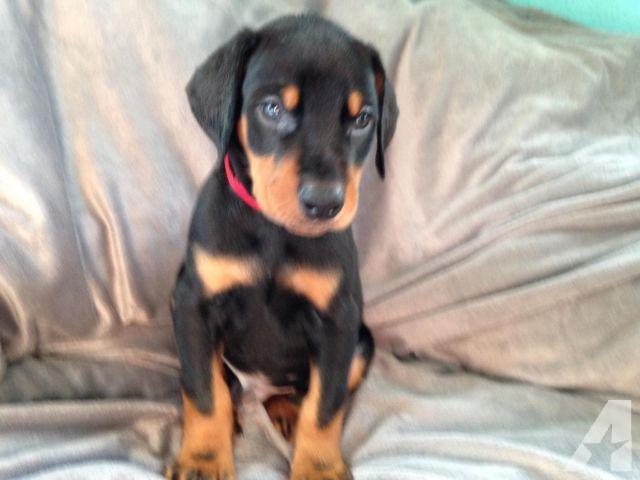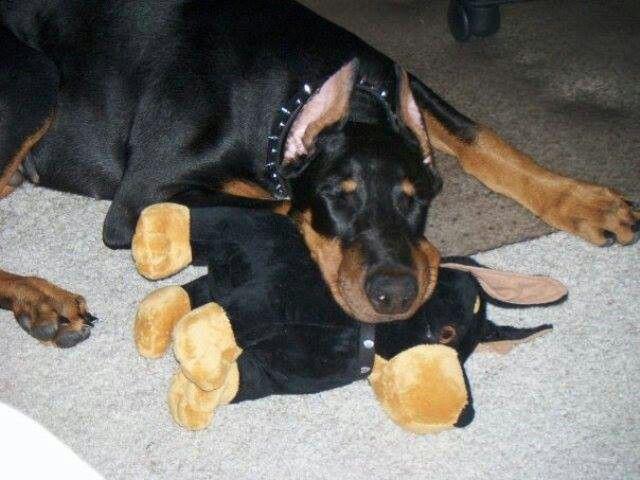The first image is the image on the left, the second image is the image on the right. Given the left and right images, does the statement "There is a total of two real dogs." hold true? Answer yes or no. Yes. The first image is the image on the left, the second image is the image on the right. Analyze the images presented: Is the assertion "There are exactly two dogs." valid? Answer yes or no. Yes. 